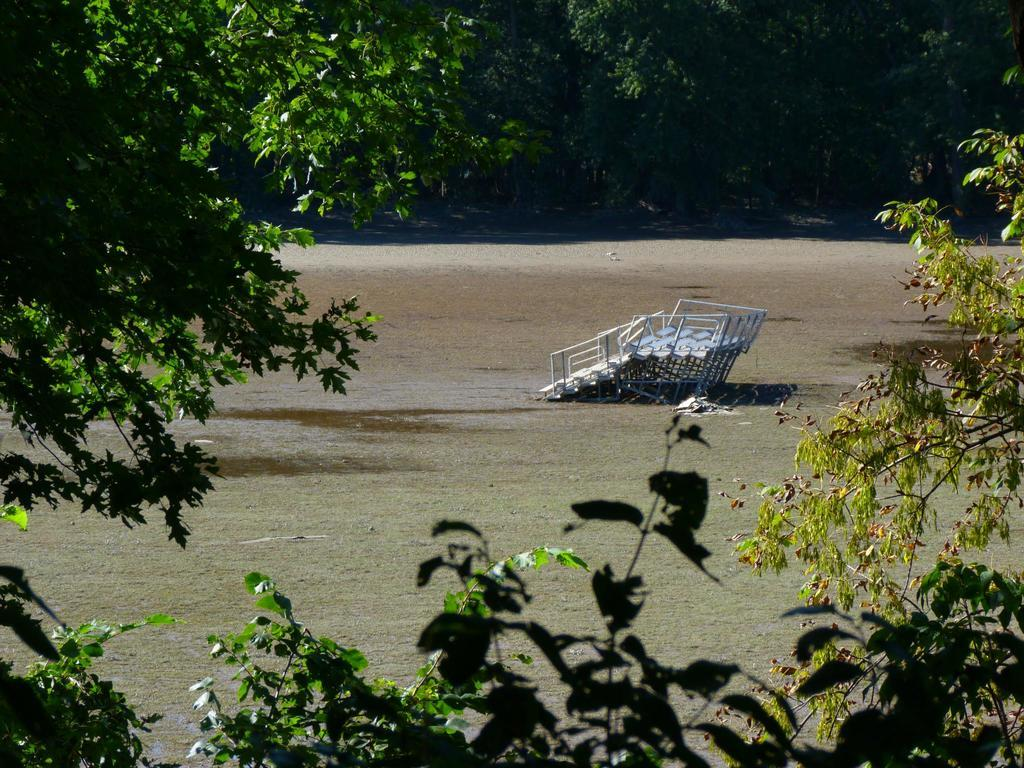What type of vegetation can be seen in the image? There are trees and plants in the image. What color are the trees and plants in the image? The trees and plants are green in color. Can you describe the object that is white in color? Unfortunately, there is no information about a white object in the provided facts. How many fingers can be seen pointing at the chalk in the image? There is no chalk or fingers present in the image. 